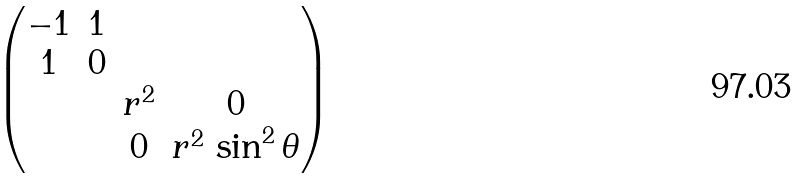<formula> <loc_0><loc_0><loc_500><loc_500>\begin{pmatrix} - 1 & 1 & & \\ 1 & 0 & & \\ & & r ^ { 2 } & 0 \\ & & 0 & r ^ { 2 } \, \sin ^ { 2 } \theta \end{pmatrix}</formula> 